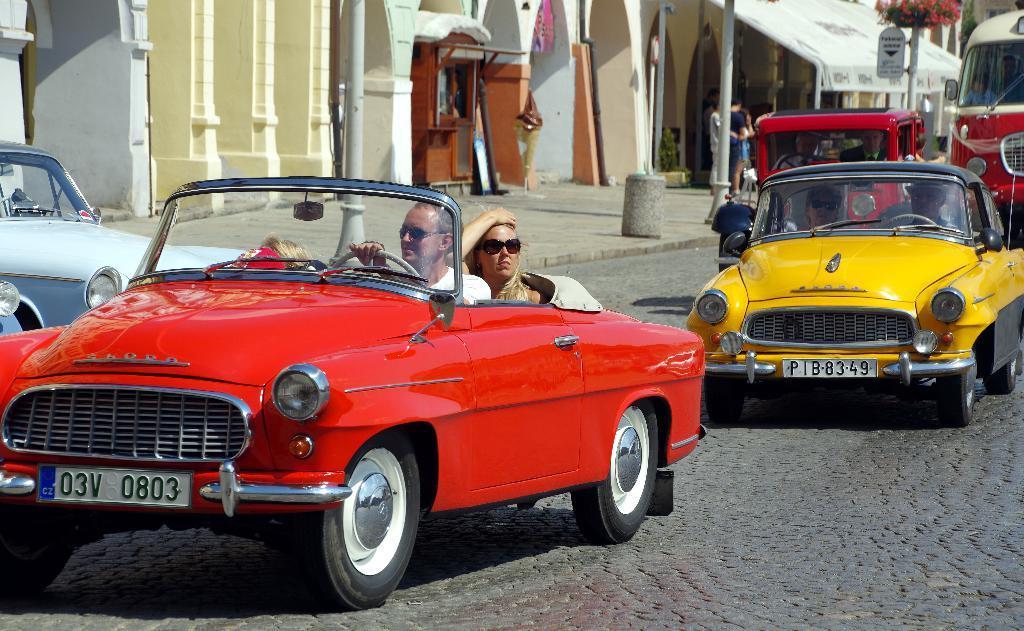Describe this image in one or two sentences. In this picture there are few persons travelling in vehicles on the road and there are few persons standing and there are poles and a building in the background. 